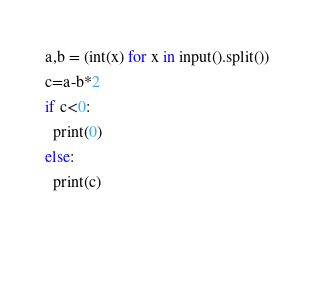Convert code to text. <code><loc_0><loc_0><loc_500><loc_500><_Python_>a,b = (int(x) for x in input().split())
c=a-b*2
if c<0:
  print(0)
else:
  print(c)
  
  </code> 